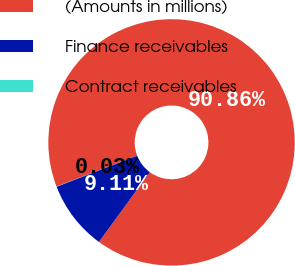Convert chart. <chart><loc_0><loc_0><loc_500><loc_500><pie_chart><fcel>(Amounts in millions)<fcel>Finance receivables<fcel>Contract receivables<nl><fcel>90.85%<fcel>9.11%<fcel>0.03%<nl></chart> 